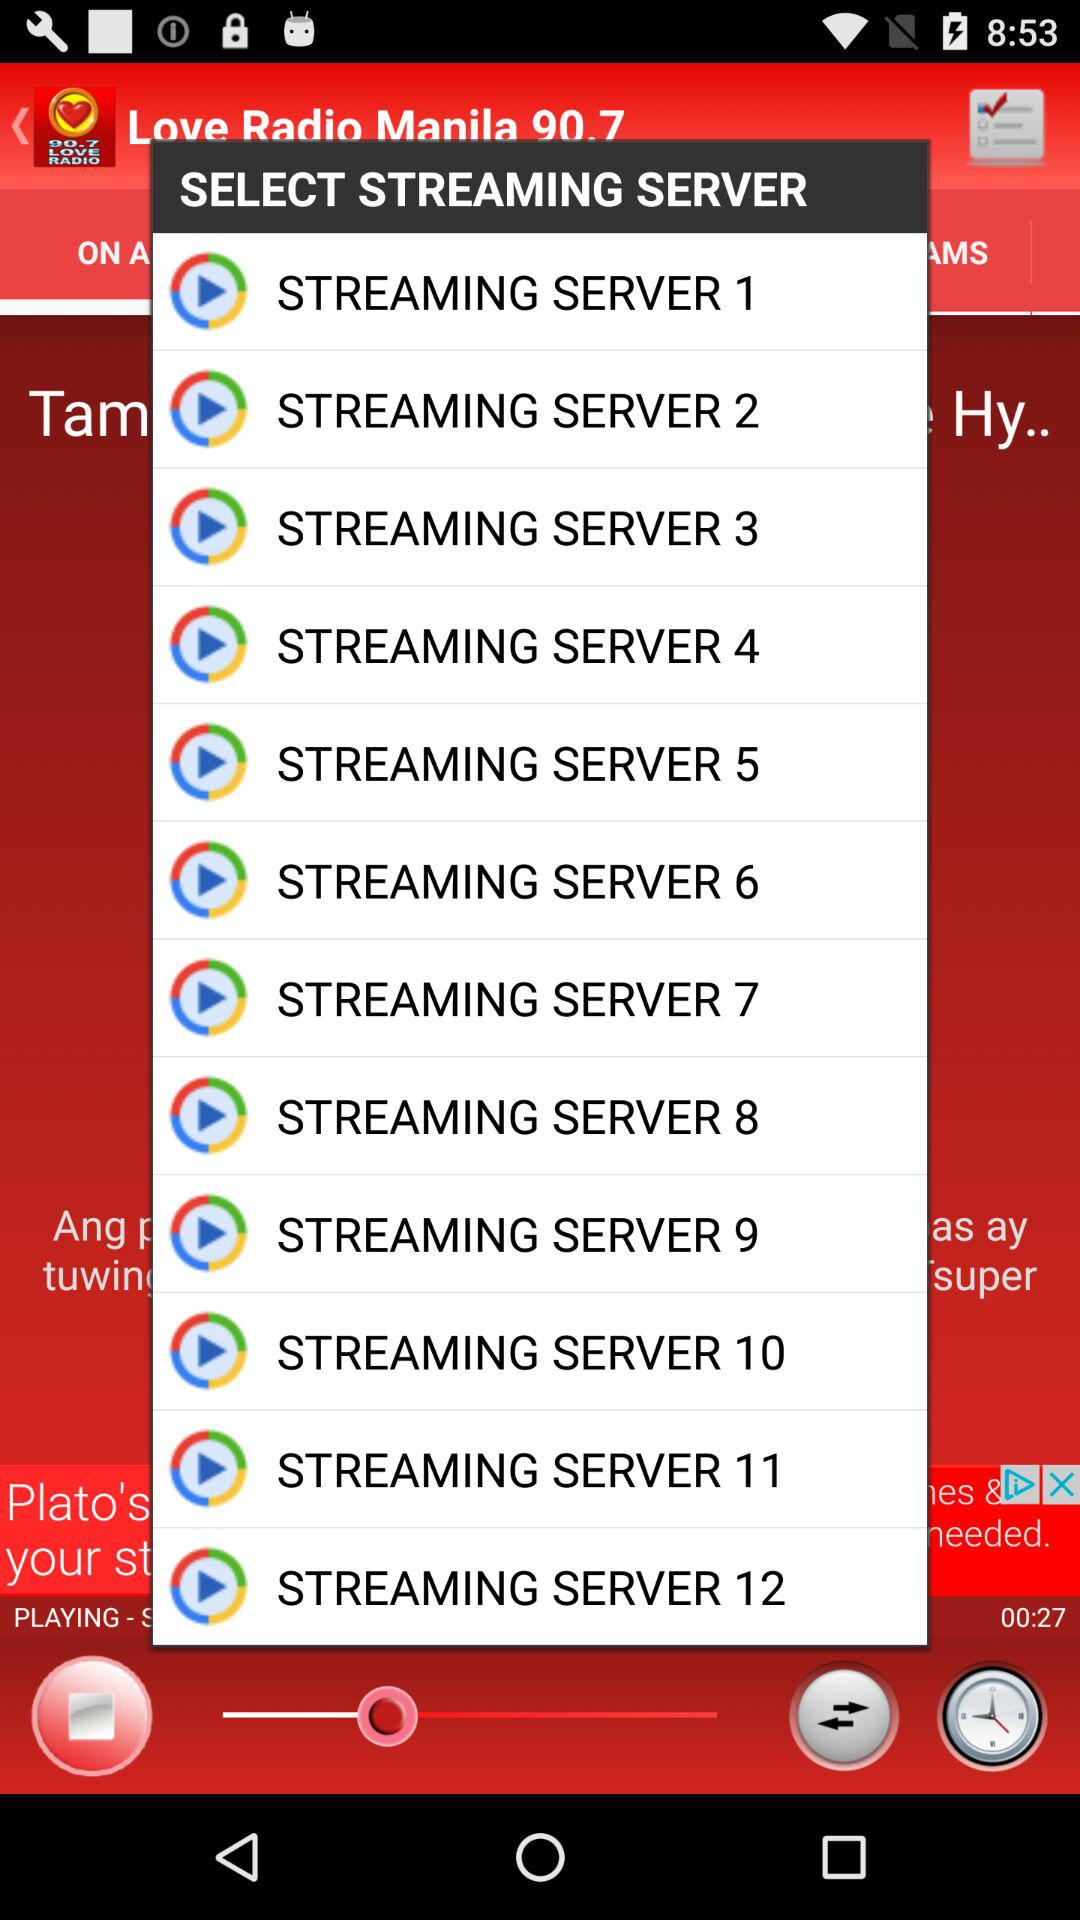How many streaming servers are below streaming server 3?
Answer the question using a single word or phrase. 9 